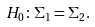Convert formula to latex. <formula><loc_0><loc_0><loc_500><loc_500>H _ { 0 } \colon \Sigma _ { 1 } = \Sigma _ { 2 } .</formula> 